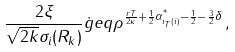<formula> <loc_0><loc_0><loc_500><loc_500>\frac { 2 \xi } { \sqrt { 2 k } \sigma _ { i } ( R _ { k } ) } \dot { g } e q \rho ^ { \frac { r T } { 2 \kappa } + \frac { 1 } { 2 } \alpha _ { \iota _ { T } ( i ) } ^ { ^ { * } } - \frac { 1 } { 2 } - \frac { 3 } { 2 } \delta } \, ,</formula> 